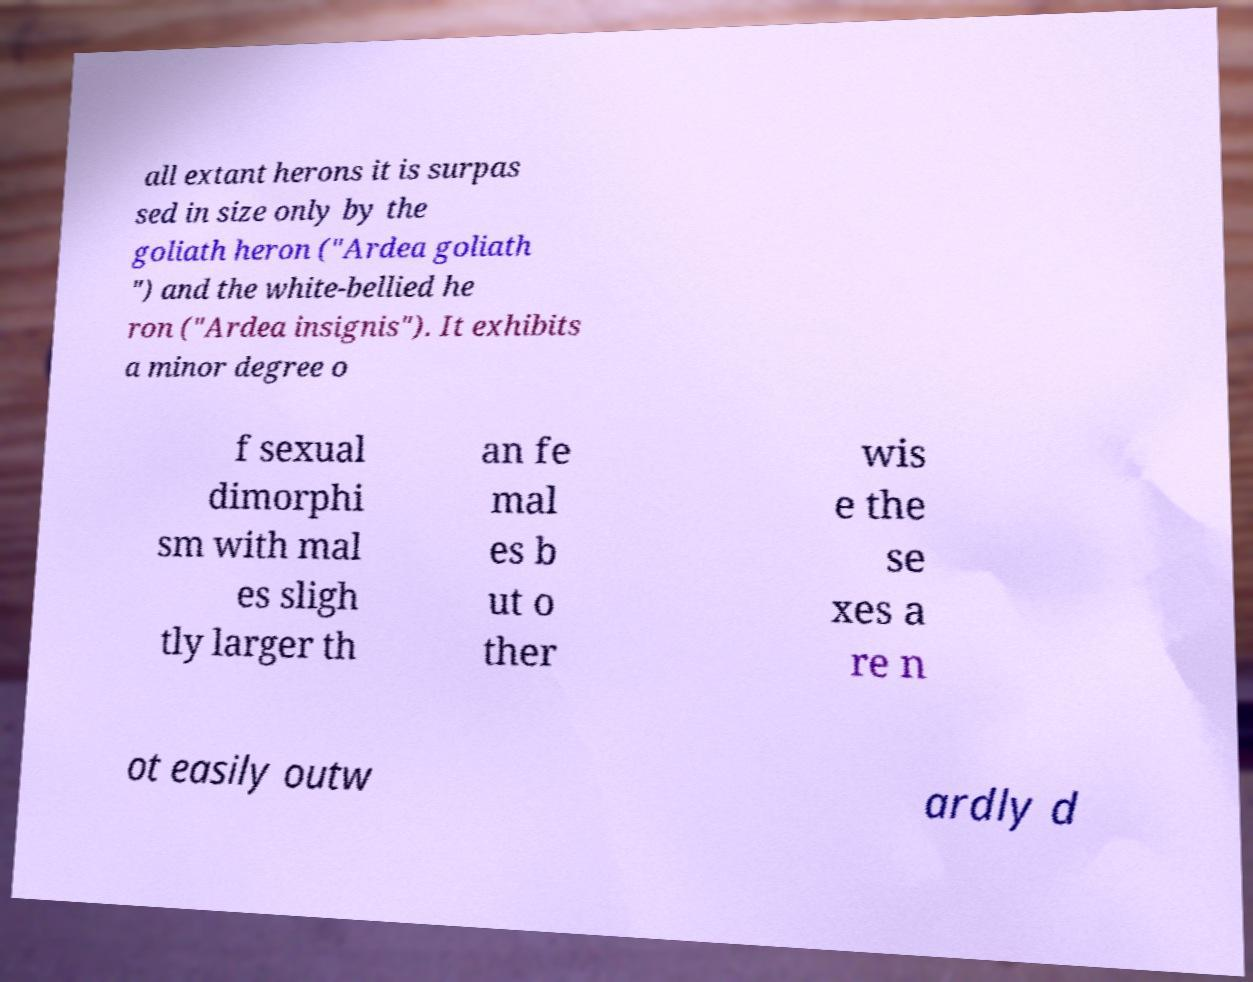Could you assist in decoding the text presented in this image and type it out clearly? all extant herons it is surpas sed in size only by the goliath heron ("Ardea goliath ") and the white-bellied he ron ("Ardea insignis"). It exhibits a minor degree o f sexual dimorphi sm with mal es sligh tly larger th an fe mal es b ut o ther wis e the se xes a re n ot easily outw ardly d 